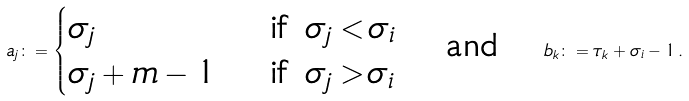<formula> <loc_0><loc_0><loc_500><loc_500>a _ { j } \colon = \begin{cases} \sigma _ { j } & \text { if } \sigma _ { j } < \sigma _ { i } \\ \sigma _ { j } + m - 1 & \text { if } \sigma _ { j } > \sigma _ { i } \end{cases} \text { \ \ and \ \ } b _ { k } \colon = \tau _ { k } + \sigma _ { i } - 1 \, .</formula> 